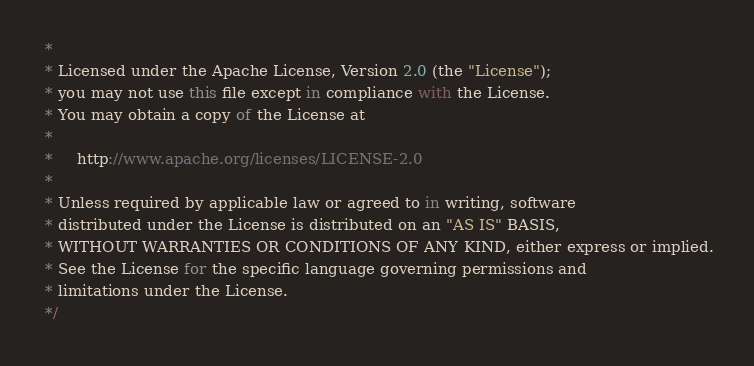<code> <loc_0><loc_0><loc_500><loc_500><_JavaScript_> *
 * Licensed under the Apache License, Version 2.0 (the "License");
 * you may not use this file except in compliance with the License.
 * You may obtain a copy of the License at
 *
 *     http://www.apache.org/licenses/LICENSE-2.0
 *
 * Unless required by applicable law or agreed to in writing, software
 * distributed under the License is distributed on an "AS IS" BASIS,
 * WITHOUT WARRANTIES OR CONDITIONS OF ANY KIND, either express or implied.
 * See the License for the specific language governing permissions and
 * limitations under the License.
 */</code> 